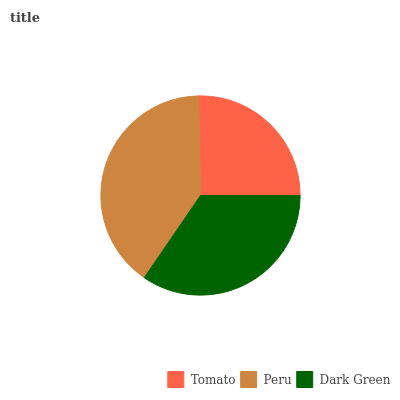Is Tomato the minimum?
Answer yes or no. Yes. Is Peru the maximum?
Answer yes or no. Yes. Is Dark Green the minimum?
Answer yes or no. No. Is Dark Green the maximum?
Answer yes or no. No. Is Peru greater than Dark Green?
Answer yes or no. Yes. Is Dark Green less than Peru?
Answer yes or no. Yes. Is Dark Green greater than Peru?
Answer yes or no. No. Is Peru less than Dark Green?
Answer yes or no. No. Is Dark Green the high median?
Answer yes or no. Yes. Is Dark Green the low median?
Answer yes or no. Yes. Is Tomato the high median?
Answer yes or no. No. Is Peru the low median?
Answer yes or no. No. 